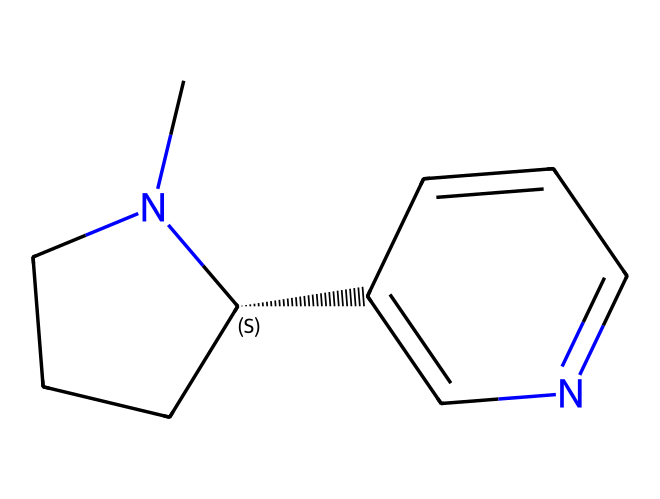What is the molecular formula of nicotine? To derive the molecular formula, count the number of each type of atom present in the SMILES representation. The structure CN1CCC[C@H]1C2=CN=CC=C2 indicates there are 10 carbon atoms (C), 14 hydrogen atoms (H), and 2 nitrogen atoms (N). Thus, the molecular formula for nicotine is C10H14N2.
Answer: C10H14N2 How many rings does nicotine contain? By analyzing the structure represented in the SMILES, observe the parts labeled with 'C' and 'N' within the brackets and the numbering. The presence of 'N1' and 'C1' indicates the start of a cyclic structure, suggesting that there are two rings connected in the molecule. Therefore, there are 2 rings in nicotine.
Answer: 2 What functional groups are present in nicotine? By examining the structure, identify the functional groups based on the types of atoms and their arrangements. Nicotine contains a pyridine ring, which includes a nitrogen atom and is part of an aromatic structure, as well as a piperidine ring. These groups give nicotine its characteristic properties.
Answer: pyridine and piperidine Is nicotine an alkaloid? Alkaloids are defined as naturally occurring organic compounds that predominantly contain basic nitrogen atoms. The structure of nicotine shows it comprises nitrogen and fits the profile of alkaloids since it is derived from tobacco and affects biological systems. Therefore, nicotine is classified as an alkaloid.
Answer: yes What is a notable property of nicotine affecting the body? Nicotine is known primarily for its stimulant effects on the central nervous system, leading to increased dopamine release in the brain. This property contributes to its addictive nature, influencing brain chemistry significantly.
Answer: stimulant 